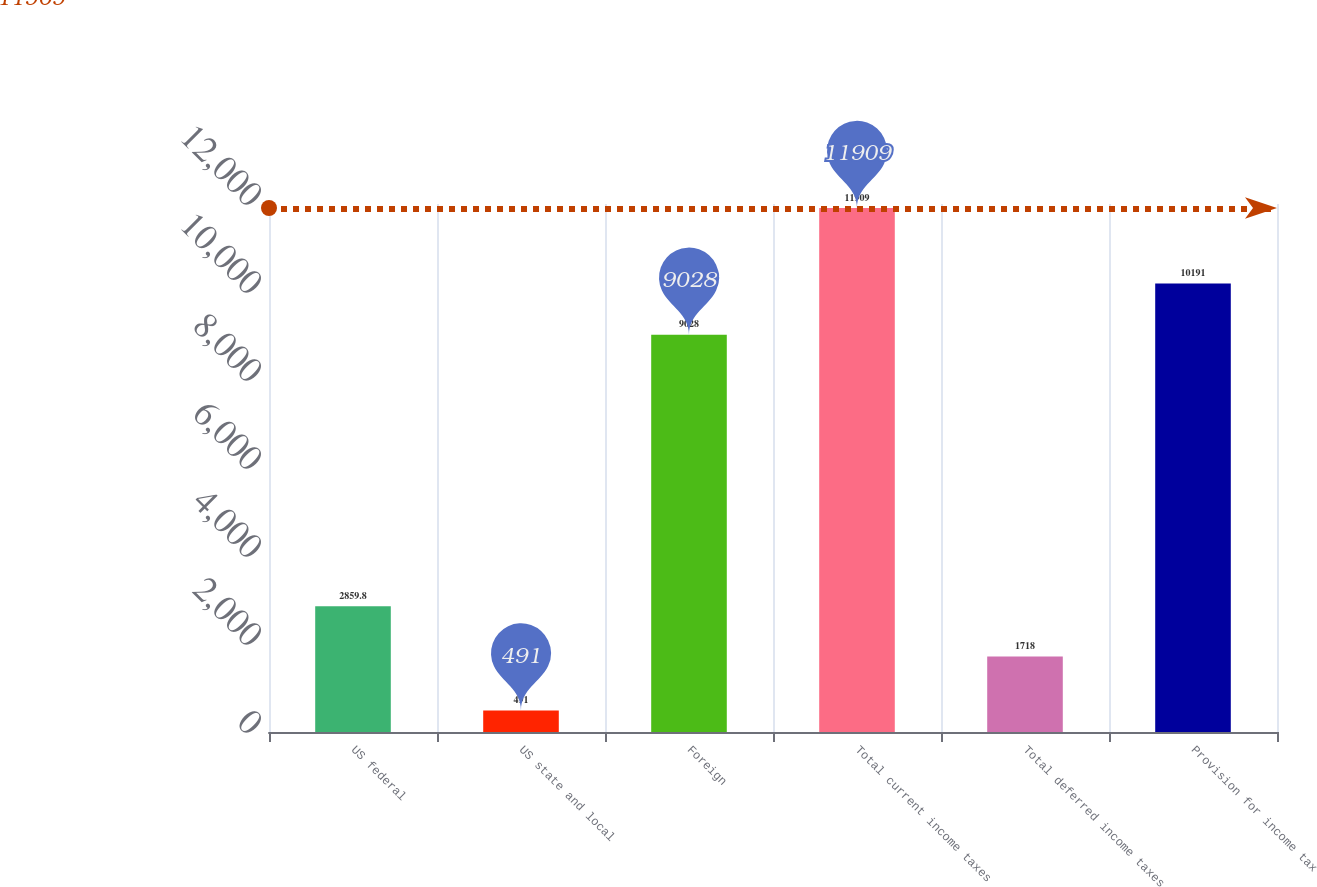<chart> <loc_0><loc_0><loc_500><loc_500><bar_chart><fcel>US federal<fcel>US state and local<fcel>Foreign<fcel>Total current income taxes<fcel>Total deferred income taxes<fcel>Provision for income tax<nl><fcel>2859.8<fcel>491<fcel>9028<fcel>11909<fcel>1718<fcel>10191<nl></chart> 